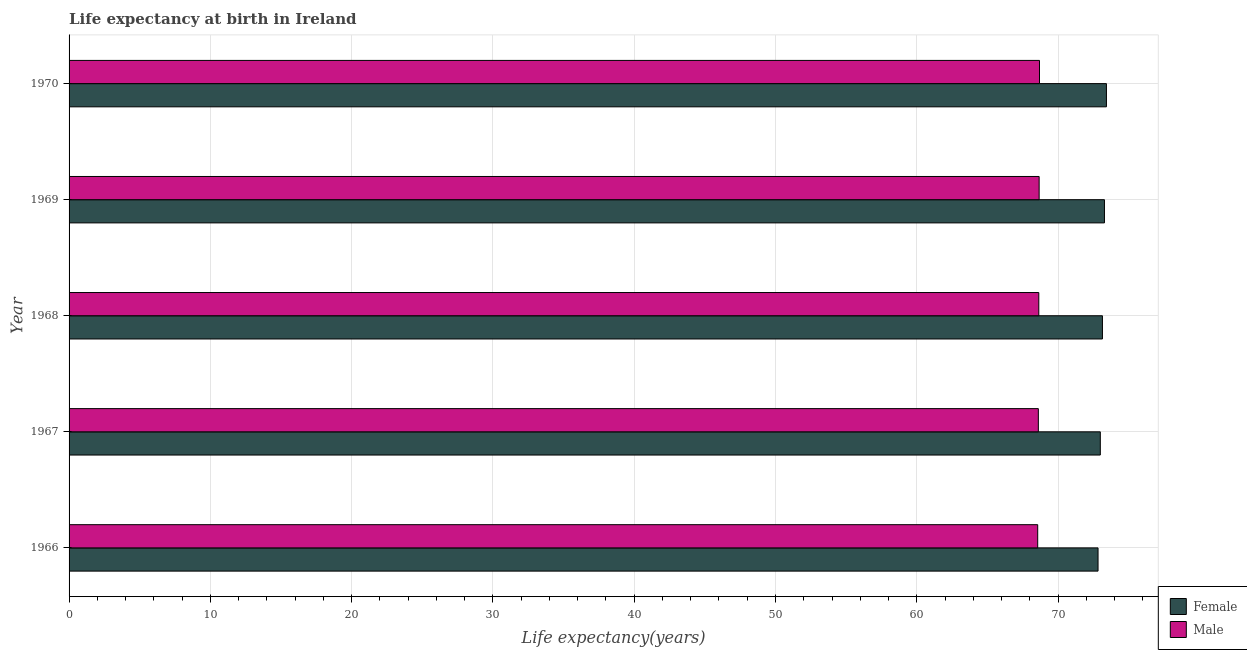How many groups of bars are there?
Offer a very short reply. 5. Are the number of bars on each tick of the Y-axis equal?
Keep it short and to the point. Yes. How many bars are there on the 1st tick from the top?
Your answer should be compact. 2. How many bars are there on the 3rd tick from the bottom?
Ensure brevity in your answer.  2. What is the label of the 4th group of bars from the top?
Your response must be concise. 1967. In how many cases, is the number of bars for a given year not equal to the number of legend labels?
Offer a terse response. 0. What is the life expectancy(female) in 1966?
Ensure brevity in your answer.  72.83. Across all years, what is the maximum life expectancy(female)?
Your answer should be compact. 73.42. Across all years, what is the minimum life expectancy(female)?
Your answer should be very brief. 72.83. In which year was the life expectancy(male) minimum?
Give a very brief answer. 1966. What is the total life expectancy(male) in the graph?
Ensure brevity in your answer.  343.14. What is the difference between the life expectancy(female) in 1969 and that in 1970?
Make the answer very short. -0.14. What is the difference between the life expectancy(female) in 1966 and the life expectancy(male) in 1967?
Keep it short and to the point. 4.22. What is the average life expectancy(female) per year?
Keep it short and to the point. 73.13. In the year 1969, what is the difference between the life expectancy(male) and life expectancy(female)?
Give a very brief answer. -4.62. What is the ratio of the life expectancy(female) in 1966 to that in 1967?
Provide a succinct answer. 1. Is the difference between the life expectancy(male) in 1967 and 1969 greater than the difference between the life expectancy(female) in 1967 and 1969?
Your answer should be compact. Yes. What is the difference between the highest and the second highest life expectancy(female)?
Offer a terse response. 0.14. What is the difference between the highest and the lowest life expectancy(female)?
Provide a succinct answer. 0.59. In how many years, is the life expectancy(female) greater than the average life expectancy(female) taken over all years?
Give a very brief answer. 3. What does the 1st bar from the top in 1970 represents?
Offer a very short reply. Male. What does the 2nd bar from the bottom in 1966 represents?
Make the answer very short. Male. Are all the bars in the graph horizontal?
Offer a terse response. Yes. How many years are there in the graph?
Keep it short and to the point. 5. What is the difference between two consecutive major ticks on the X-axis?
Give a very brief answer. 10. Are the values on the major ticks of X-axis written in scientific E-notation?
Offer a very short reply. No. How are the legend labels stacked?
Provide a succinct answer. Vertical. What is the title of the graph?
Offer a terse response. Life expectancy at birth in Ireland. Does "Lower secondary rate" appear as one of the legend labels in the graph?
Offer a very short reply. No. What is the label or title of the X-axis?
Your answer should be very brief. Life expectancy(years). What is the label or title of the Y-axis?
Provide a short and direct response. Year. What is the Life expectancy(years) of Female in 1966?
Provide a short and direct response. 72.83. What is the Life expectancy(years) in Male in 1966?
Make the answer very short. 68.56. What is the Life expectancy(years) of Female in 1967?
Ensure brevity in your answer.  72.99. What is the Life expectancy(years) of Male in 1967?
Give a very brief answer. 68.6. What is the Life expectancy(years) of Female in 1968?
Keep it short and to the point. 73.14. What is the Life expectancy(years) of Male in 1968?
Make the answer very short. 68.64. What is the Life expectancy(years) of Female in 1969?
Make the answer very short. 73.28. What is the Life expectancy(years) in Male in 1969?
Your answer should be very brief. 68.66. What is the Life expectancy(years) in Female in 1970?
Provide a short and direct response. 73.42. What is the Life expectancy(years) of Male in 1970?
Make the answer very short. 68.69. Across all years, what is the maximum Life expectancy(years) in Female?
Your answer should be very brief. 73.42. Across all years, what is the maximum Life expectancy(years) of Male?
Your answer should be very brief. 68.69. Across all years, what is the minimum Life expectancy(years) of Female?
Your response must be concise. 72.83. Across all years, what is the minimum Life expectancy(years) of Male?
Ensure brevity in your answer.  68.56. What is the total Life expectancy(years) of Female in the graph?
Ensure brevity in your answer.  365.67. What is the total Life expectancy(years) in Male in the graph?
Your answer should be very brief. 343.14. What is the difference between the Life expectancy(years) in Female in 1966 and that in 1967?
Keep it short and to the point. -0.16. What is the difference between the Life expectancy(years) in Male in 1966 and that in 1967?
Your answer should be very brief. -0.05. What is the difference between the Life expectancy(years) in Female in 1966 and that in 1968?
Offer a very short reply. -0.31. What is the difference between the Life expectancy(years) of Male in 1966 and that in 1968?
Your answer should be very brief. -0.08. What is the difference between the Life expectancy(years) of Female in 1966 and that in 1969?
Provide a short and direct response. -0.45. What is the difference between the Life expectancy(years) of Male in 1966 and that in 1969?
Offer a terse response. -0.1. What is the difference between the Life expectancy(years) of Female in 1966 and that in 1970?
Provide a short and direct response. -0.59. What is the difference between the Life expectancy(years) of Male in 1966 and that in 1970?
Provide a succinct answer. -0.13. What is the difference between the Life expectancy(years) of Female in 1967 and that in 1968?
Keep it short and to the point. -0.15. What is the difference between the Life expectancy(years) of Male in 1967 and that in 1968?
Provide a succinct answer. -0.03. What is the difference between the Life expectancy(years) of Female in 1967 and that in 1969?
Give a very brief answer. -0.29. What is the difference between the Life expectancy(years) of Male in 1967 and that in 1969?
Keep it short and to the point. -0.06. What is the difference between the Life expectancy(years) in Female in 1967 and that in 1970?
Your answer should be very brief. -0.43. What is the difference between the Life expectancy(years) in Male in 1967 and that in 1970?
Your answer should be compact. -0.08. What is the difference between the Life expectancy(years) of Female in 1968 and that in 1969?
Make the answer very short. -0.14. What is the difference between the Life expectancy(years) of Male in 1968 and that in 1969?
Provide a succinct answer. -0.02. What is the difference between the Life expectancy(years) in Female in 1968 and that in 1970?
Provide a short and direct response. -0.28. What is the difference between the Life expectancy(years) in Male in 1968 and that in 1970?
Your answer should be very brief. -0.05. What is the difference between the Life expectancy(years) in Female in 1969 and that in 1970?
Ensure brevity in your answer.  -0.14. What is the difference between the Life expectancy(years) in Male in 1969 and that in 1970?
Keep it short and to the point. -0.03. What is the difference between the Life expectancy(years) in Female in 1966 and the Life expectancy(years) in Male in 1967?
Give a very brief answer. 4.22. What is the difference between the Life expectancy(years) in Female in 1966 and the Life expectancy(years) in Male in 1968?
Keep it short and to the point. 4.19. What is the difference between the Life expectancy(years) of Female in 1966 and the Life expectancy(years) of Male in 1969?
Make the answer very short. 4.17. What is the difference between the Life expectancy(years) in Female in 1966 and the Life expectancy(years) in Male in 1970?
Offer a very short reply. 4.14. What is the difference between the Life expectancy(years) in Female in 1967 and the Life expectancy(years) in Male in 1968?
Your response must be concise. 4.35. What is the difference between the Life expectancy(years) of Female in 1967 and the Life expectancy(years) of Male in 1969?
Give a very brief answer. 4.33. What is the difference between the Life expectancy(years) in Female in 1967 and the Life expectancy(years) in Male in 1970?
Offer a terse response. 4.3. What is the difference between the Life expectancy(years) of Female in 1968 and the Life expectancy(years) of Male in 1969?
Provide a short and direct response. 4.48. What is the difference between the Life expectancy(years) of Female in 1968 and the Life expectancy(years) of Male in 1970?
Make the answer very short. 4.46. What is the difference between the Life expectancy(years) of Female in 1969 and the Life expectancy(years) of Male in 1970?
Make the answer very short. 4.6. What is the average Life expectancy(years) in Female per year?
Make the answer very short. 73.13. What is the average Life expectancy(years) of Male per year?
Make the answer very short. 68.63. In the year 1966, what is the difference between the Life expectancy(years) of Female and Life expectancy(years) of Male?
Offer a terse response. 4.27. In the year 1967, what is the difference between the Life expectancy(years) in Female and Life expectancy(years) in Male?
Keep it short and to the point. 4.39. In the year 1968, what is the difference between the Life expectancy(years) of Female and Life expectancy(years) of Male?
Keep it short and to the point. 4.5. In the year 1969, what is the difference between the Life expectancy(years) in Female and Life expectancy(years) in Male?
Make the answer very short. 4.62. In the year 1970, what is the difference between the Life expectancy(years) of Female and Life expectancy(years) of Male?
Offer a very short reply. 4.74. What is the ratio of the Life expectancy(years) in Male in 1966 to that in 1967?
Give a very brief answer. 1. What is the ratio of the Life expectancy(years) in Female in 1966 to that in 1968?
Your response must be concise. 1. What is the ratio of the Life expectancy(years) in Female in 1966 to that in 1969?
Offer a terse response. 0.99. What is the ratio of the Life expectancy(years) of Male in 1966 to that in 1969?
Your answer should be compact. 1. What is the ratio of the Life expectancy(years) of Female in 1966 to that in 1970?
Offer a terse response. 0.99. What is the ratio of the Life expectancy(years) of Female in 1967 to that in 1968?
Ensure brevity in your answer.  1. What is the ratio of the Life expectancy(years) in Male in 1967 to that in 1969?
Your answer should be very brief. 1. What is the ratio of the Life expectancy(years) in Male in 1967 to that in 1970?
Provide a succinct answer. 1. What is the ratio of the Life expectancy(years) in Female in 1968 to that in 1969?
Give a very brief answer. 1. What is the ratio of the Life expectancy(years) of Male in 1968 to that in 1969?
Keep it short and to the point. 1. What is the ratio of the Life expectancy(years) of Male in 1969 to that in 1970?
Give a very brief answer. 1. What is the difference between the highest and the second highest Life expectancy(years) of Female?
Offer a terse response. 0.14. What is the difference between the highest and the second highest Life expectancy(years) of Male?
Your response must be concise. 0.03. What is the difference between the highest and the lowest Life expectancy(years) of Female?
Offer a very short reply. 0.59. What is the difference between the highest and the lowest Life expectancy(years) of Male?
Keep it short and to the point. 0.13. 